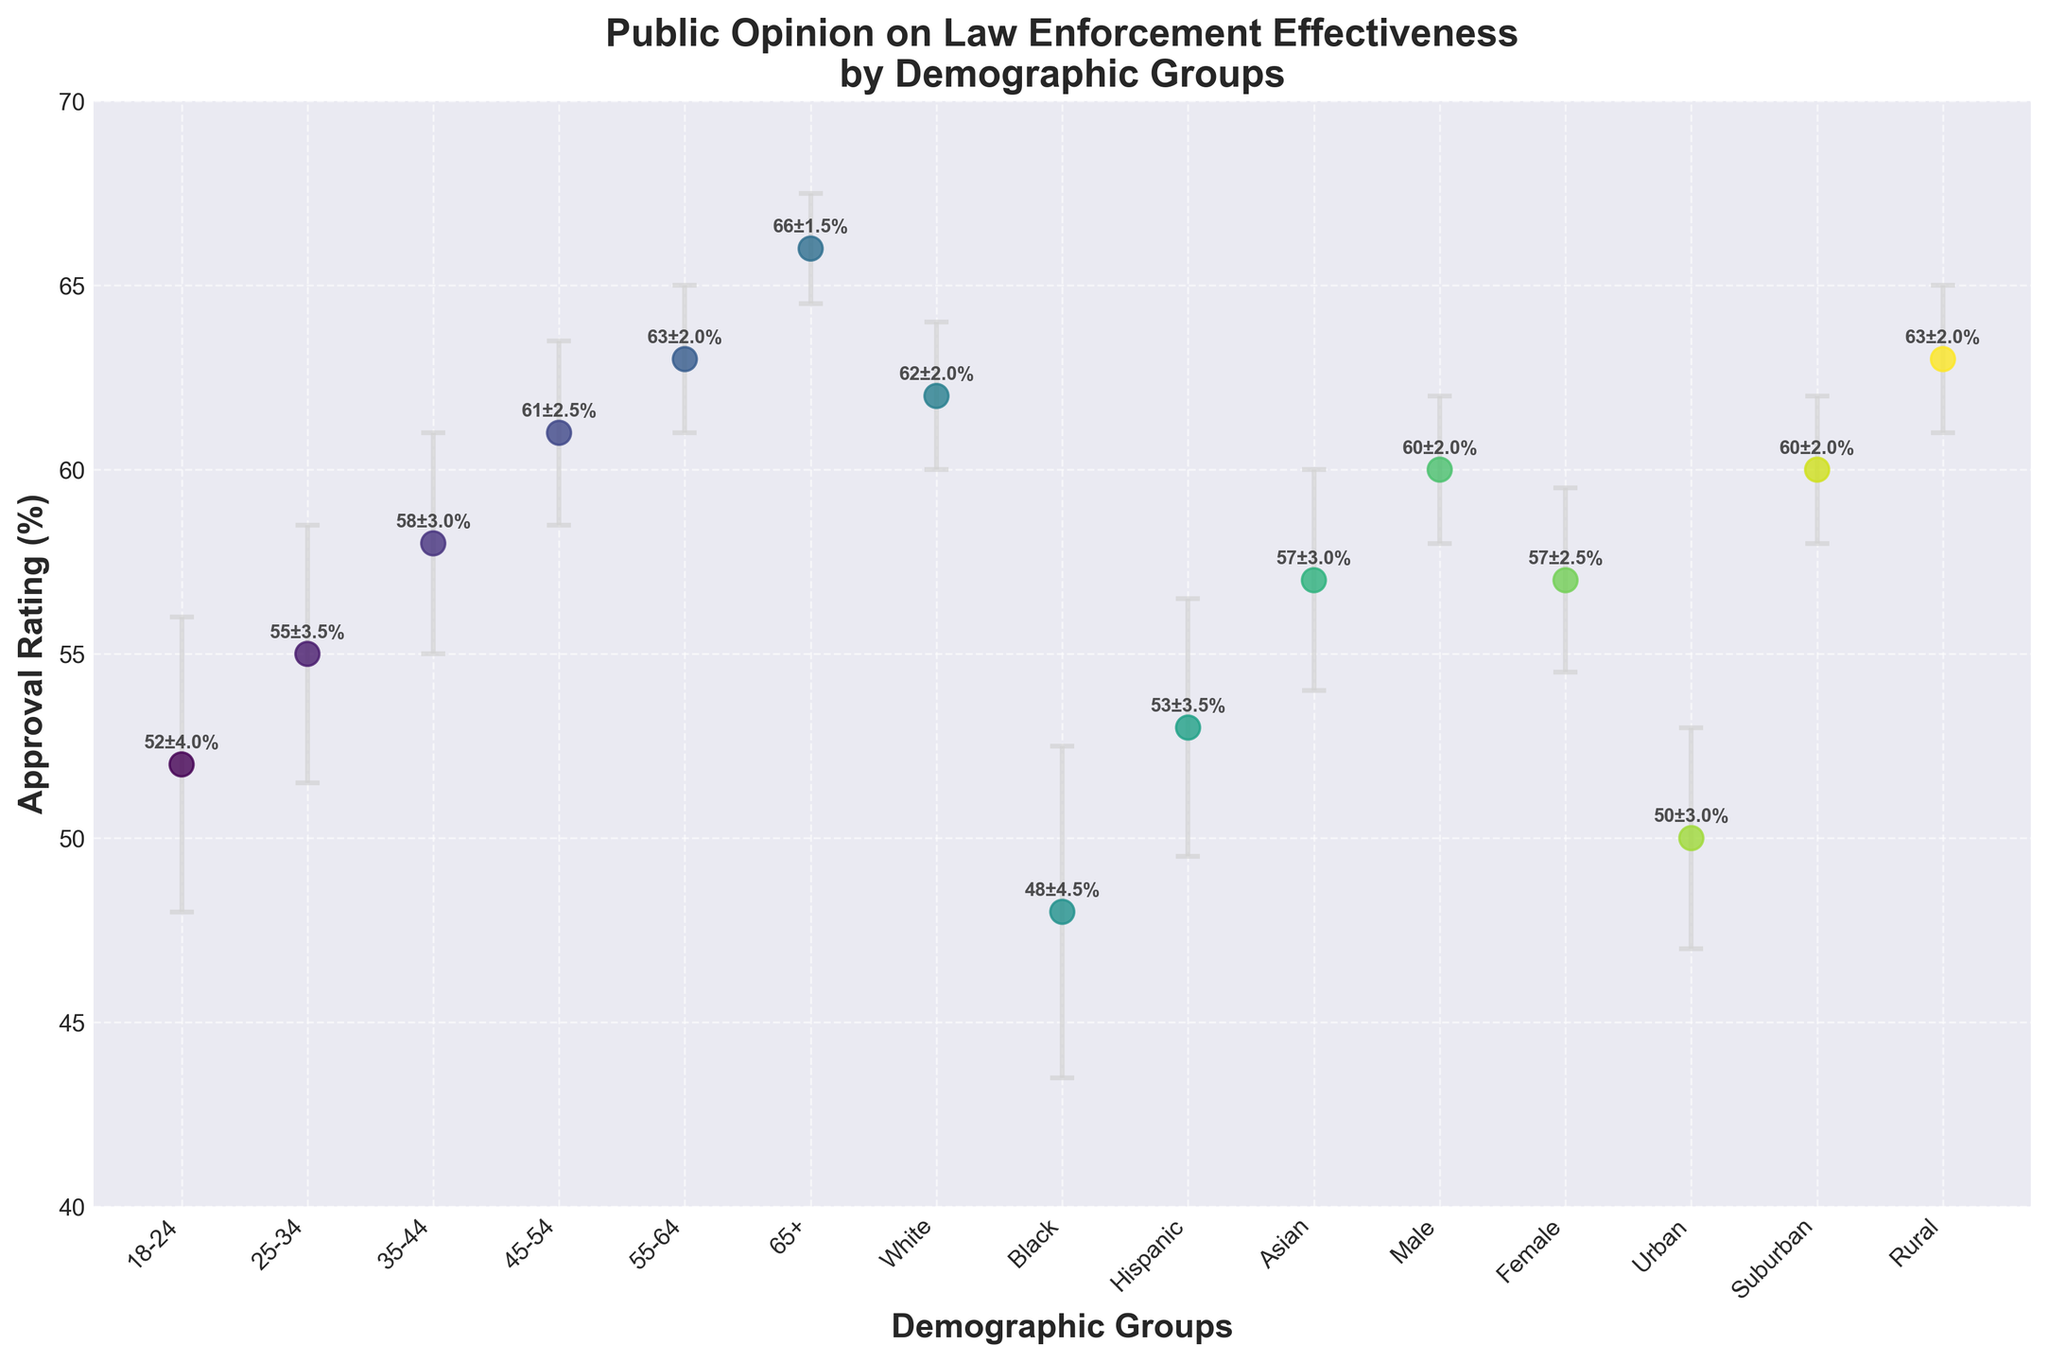What is the title of the plot? The title of the plot is displayed prominently above the scatter plot, describing the subject of the data being visualized.
Answer: Public Opinion on Law Enforcement Effectiveness by Demographic Groups How many demographic groups are represented in the plot? Count the number of distinct categories on the x-axis, each representing a demographic group. There are 15 unique demographic groups listed.
Answer: 15 Which demographic group has the highest approval rating of law enforcement effectiveness? Identify the point with the highest y-value on the scatter plot. The chart indicates that the 65+ age group has the highest rating of 66%.
Answer: 65+ What is the approval rating range of the 18-24 age group and its error margin? Locate the data point for the 18-24 age group and note its y-value and the extent of its error bars. The approval rating for the 18-24 age group is 52% ± 4%.
Answer: 52% ± 4% How does the approval rating of suburban residents compare to that of urban residents? Look at the data points for suburban and urban residents and compare their y-values. Suburban residents have an approval rating of 60%, while urban residents have 50%.
Answer: Suburban residents have a higher approval rating What is the difference in approval ratings between males and females? Find the y-values for male and female demographic groups and subtract the smaller value from the larger one. Males have an approval rating of 60%, and females have 57%. The difference is 60% - 57% = 3%.
Answer: 3% Which demographic group has the largest error margin in their approval rating? The size of the error bars represents the error margin. The Black demographic group has the largest error margin of 4.5%.
Answer: Black What are the approval ratings and error margins for the age groups 35-44 and 45-54, and how do they compare? Check the y-values and error bars for the 35-44 and 45-54 age groups on the scatter plot. The 35-44 age group has an approval rating of 58% ± 3%, and the 45-54 age group has an approval rating of 61% ± 2.5%. This shows that the 45-54 age group has a higher approval rating, and both groups have low error margins.
Answer: 35-44: 58% ± 3%, 45-54: 61% ± 2.5%, 45-54 has higher What is the average approval rating of all the age groups? Add the approval ratings of all age groups (52 + 55 + 58 + 61 + 63 + 66) and then divide by the number of age groups (6). The sum is 355%, and the average is 355 / 6 ≈ 59.17%.
Answer: 59.17% Which demographic group has an approval rating closest to 60% with the error margin included? Look for data points where the approval rating ± error margin includes 60%. Suburban and Rural groups have approval ratings of 60% and 63% respectively, but Urban’s error margin (50% ± 3%) does not include 60%. The 25-34 age group has an approval rating of 55% with an error margin of 3.5%. So, the closest is around suburban.
Answer: Suburban 